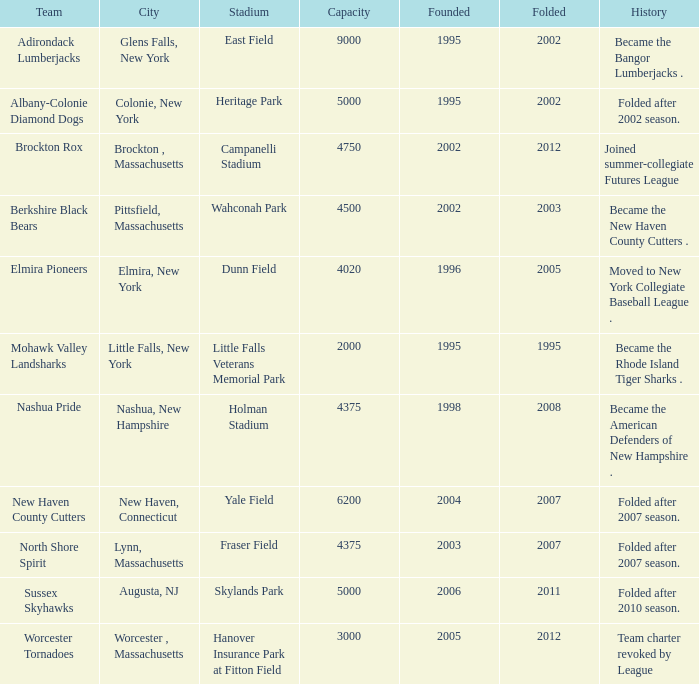What is the highest folded value for the team that plays at fraser field? 2007.0. Could you parse the entire table? {'header': ['Team', 'City', 'Stadium', 'Capacity', 'Founded', 'Folded', 'History'], 'rows': [['Adirondack Lumberjacks', 'Glens Falls, New York', 'East Field', '9000', '1995', '2002', 'Became the Bangor Lumberjacks .'], ['Albany-Colonie Diamond Dogs', 'Colonie, New York', 'Heritage Park', '5000', '1995', '2002', 'Folded after 2002 season.'], ['Brockton Rox', 'Brockton , Massachusetts', 'Campanelli Stadium', '4750', '2002', '2012', 'Joined summer-collegiate Futures League'], ['Berkshire Black Bears', 'Pittsfield, Massachusetts', 'Wahconah Park', '4500', '2002', '2003', 'Became the New Haven County Cutters .'], ['Elmira Pioneers', 'Elmira, New York', 'Dunn Field', '4020', '1996', '2005', 'Moved to New York Collegiate Baseball League .'], ['Mohawk Valley Landsharks', 'Little Falls, New York', 'Little Falls Veterans Memorial Park', '2000', '1995', '1995', 'Became the Rhode Island Tiger Sharks .'], ['Nashua Pride', 'Nashua, New Hampshire', 'Holman Stadium', '4375', '1998', '2008', 'Became the American Defenders of New Hampshire .'], ['New Haven County Cutters', 'New Haven, Connecticut', 'Yale Field', '6200', '2004', '2007', 'Folded after 2007 season.'], ['North Shore Spirit', 'Lynn, Massachusetts', 'Fraser Field', '4375', '2003', '2007', 'Folded after 2007 season.'], ['Sussex Skyhawks', 'Augusta, NJ', 'Skylands Park', '5000', '2006', '2011', 'Folded after 2010 season.'], ['Worcester Tornadoes', 'Worcester , Massachusetts', 'Hanover Insurance Park at Fitton Field', '3000', '2005', '2012', 'Team charter revoked by League']]} 